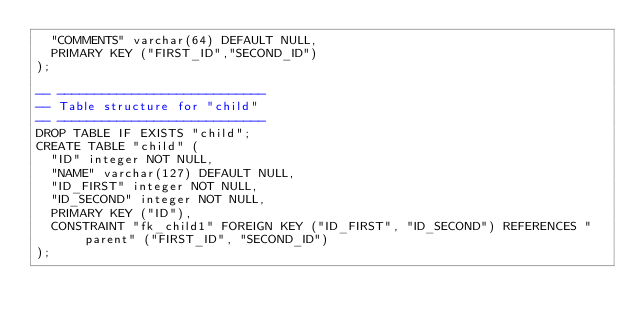<code> <loc_0><loc_0><loc_500><loc_500><_SQL_>  "COMMENTS" varchar(64) DEFAULT NULL,
  PRIMARY KEY ("FIRST_ID","SECOND_ID")
);

-- ----------------------------
-- Table structure for "child"
-- ----------------------------
DROP TABLE IF EXISTS "child";
CREATE TABLE "child" (
  "ID" integer NOT NULL,
  "NAME" varchar(127) DEFAULT NULL,
  "ID_FIRST" integer NOT NULL,
  "ID_SECOND" integer NOT NULL,
  PRIMARY KEY ("ID"),
  CONSTRAINT "fk_child1" FOREIGN KEY ("ID_FIRST", "ID_SECOND") REFERENCES "parent" ("FIRST_ID", "SECOND_ID")
);

</code> 